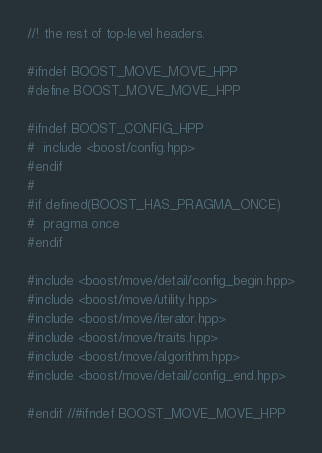Convert code to text. <code><loc_0><loc_0><loc_500><loc_500><_C++_>//! the rest of top-level headers.

#ifndef BOOST_MOVE_MOVE_HPP
#define BOOST_MOVE_MOVE_HPP

#ifndef BOOST_CONFIG_HPP
#  include <boost/config.hpp>
#endif
#
#if defined(BOOST_HAS_PRAGMA_ONCE)
#  pragma once
#endif

#include <boost/move/detail/config_begin.hpp>
#include <boost/move/utility.hpp>
#include <boost/move/iterator.hpp>
#include <boost/move/traits.hpp>
#include <boost/move/algorithm.hpp>
#include <boost/move/detail/config_end.hpp>

#endif //#ifndef BOOST_MOVE_MOVE_HPP
</code> 